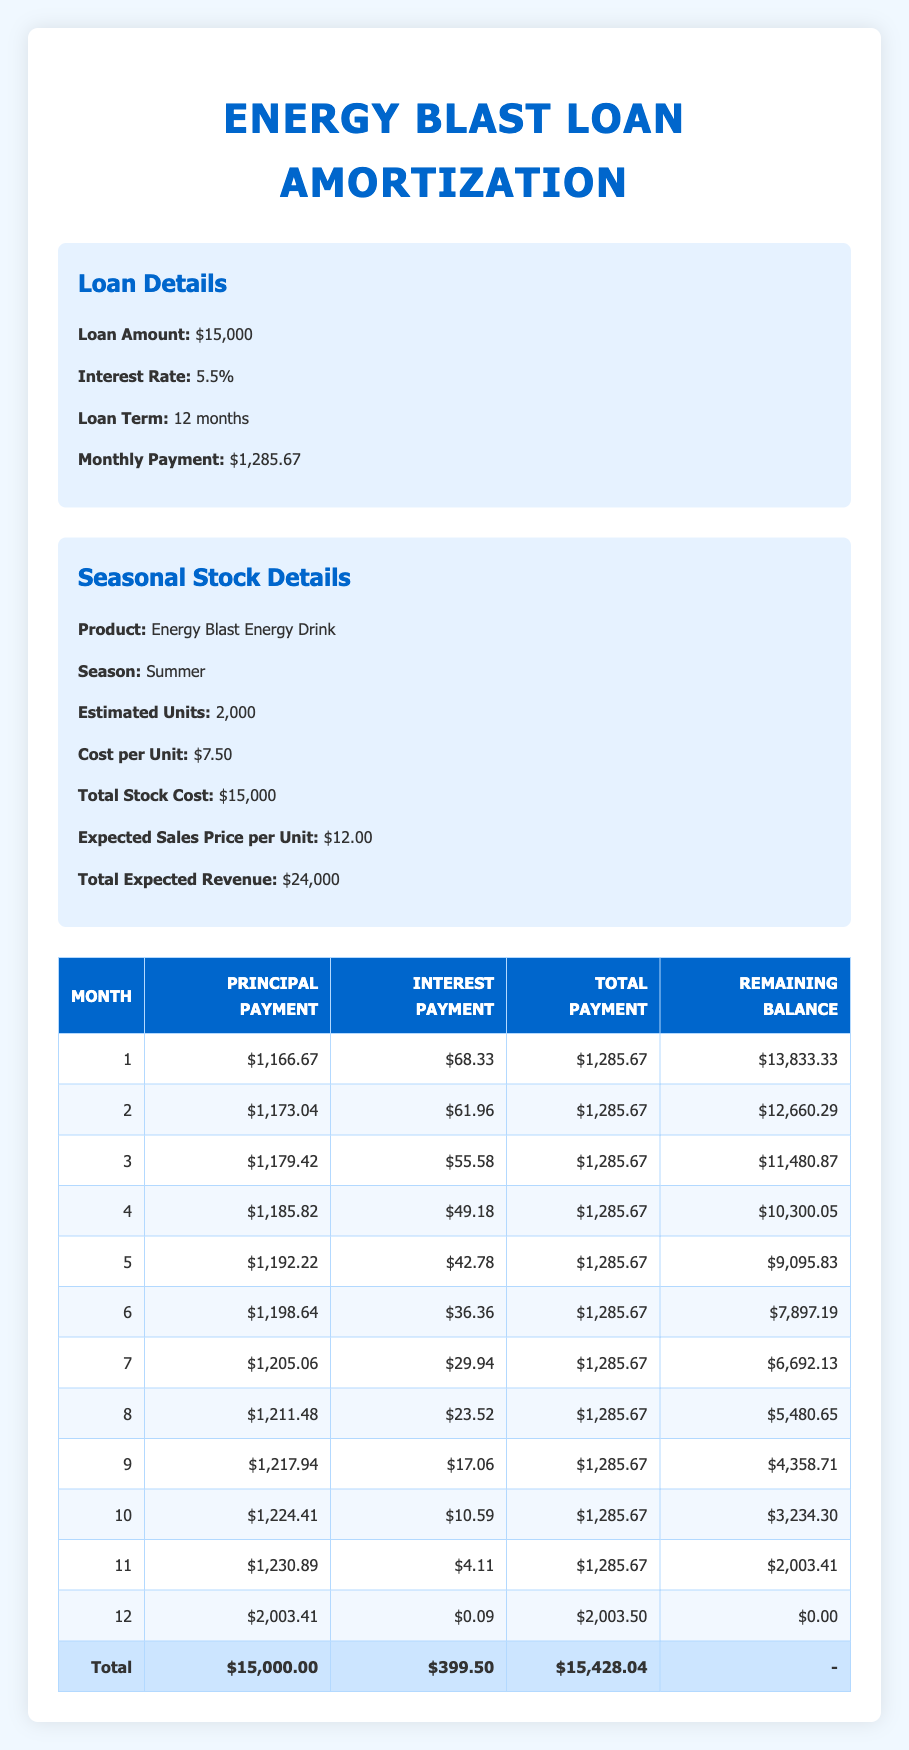What is the total principal payment made over the 12 months? The total principal payment is calculated by summing up all the monthly principal payments listed in the table. Adding them together gives: 1166.67 + 1173.04 + 1179.42 + 1185.82 + 1192.22 + 1198.64 + 1205.06 + 1211.48 + 1217.94 + 1224.41 + 1230.89 + 2003.41 = 15000
Answer: 15000 What is the remaining balance after the 6th month? The remaining balance after the 6th month is specified directly in the table. It states that the remaining balance is 7897.19 after the 6th month.
Answer: 7897.19 Is the monthly payment amount consistent throughout the loan term? Yes, the monthly payment of $1285.67 remains the same for all 12 months as indicated in the table.
Answer: Yes What is the total interest paid over the loan term? To find the total interest paid, sum all the interest payments for each month: 68.33 + 61.96 + 55.58 + 49.18 + 42.78 + 36.36 + 29.94 + 23.52 + 17.06 + 10.59 + 4.11 + 0.09 = 399.50.
Answer: 399.50 How much is the principal payment in the last month? The last month's principal payment is explicitly listed in the table as 2003.41.
Answer: 2003.41 After the second month, what is the reduction in the remaining balance compared to the first month? The remaining balance after the first month is 13833.33 and after the second month, it is 12660.29. The reduction is therefore 13833.33 - 12660.29 = 1173.04.
Answer: 1173.04 What proportion of the total expected revenue is the cost of inventory? The total expected revenue is $24000 and the total stock cost is $15000. The proportion is calculated as 15000/24000 = 0.625, which means the cost of inventory represents 62.5% of the expected revenue.
Answer: 62.5% How does the interest payment change from the first to the last month? The first month's interest payment is 68.33 and the last month's interest payment is only 0.09. The change can be calculated as 68.33 - 0.09 = 68.24, indicating a decrease of 68.24.
Answer: 68.24 What is the expected profit from selling all units of the energy drink? The expected profit can be calculated by subtracting the total stock cost from total expected revenue. Profit = 24000 - 15000 = 9000.
Answer: 9000 